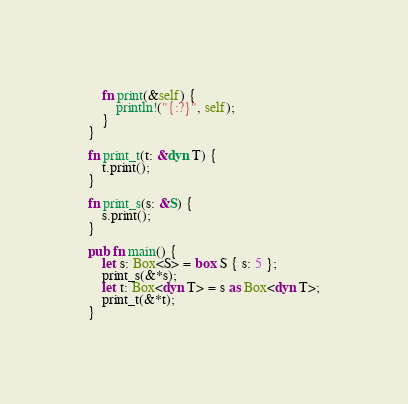Convert code to text. <code><loc_0><loc_0><loc_500><loc_500><_Rust_>    fn print(&self) {
        println!("{:?}", self);
    }
}

fn print_t(t: &dyn T) {
    t.print();
}

fn print_s(s: &S) {
    s.print();
}

pub fn main() {
    let s: Box<S> = box S { s: 5 };
    print_s(&*s);
    let t: Box<dyn T> = s as Box<dyn T>;
    print_t(&*t);
}
</code> 